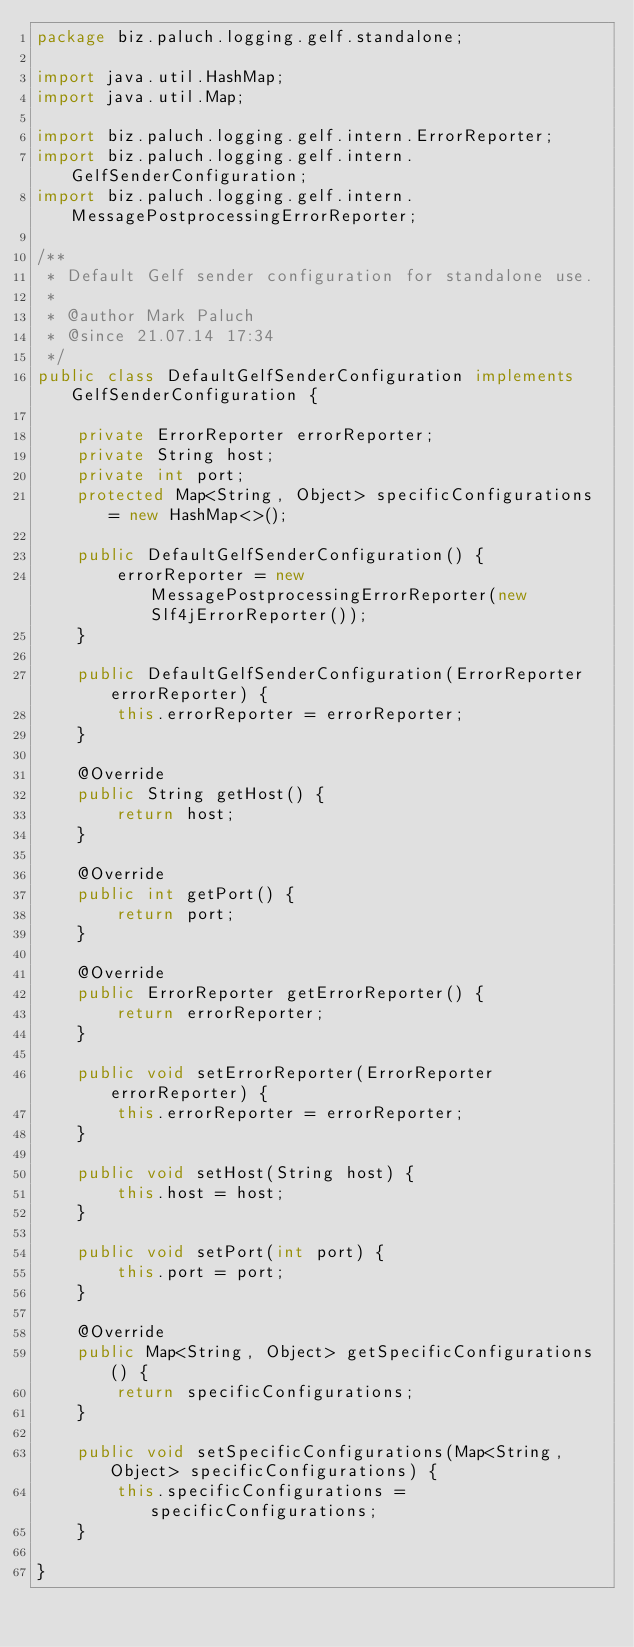<code> <loc_0><loc_0><loc_500><loc_500><_Java_>package biz.paluch.logging.gelf.standalone;

import java.util.HashMap;
import java.util.Map;

import biz.paluch.logging.gelf.intern.ErrorReporter;
import biz.paluch.logging.gelf.intern.GelfSenderConfiguration;
import biz.paluch.logging.gelf.intern.MessagePostprocessingErrorReporter;

/**
 * Default Gelf sender configuration for standalone use.
 *
 * @author Mark Paluch
 * @since 21.07.14 17:34
 */
public class DefaultGelfSenderConfiguration implements GelfSenderConfiguration {

    private ErrorReporter errorReporter;
    private String host;
    private int port;
    protected Map<String, Object> specificConfigurations = new HashMap<>();

    public DefaultGelfSenderConfiguration() {
        errorReporter = new MessagePostprocessingErrorReporter(new Slf4jErrorReporter());
    }

    public DefaultGelfSenderConfiguration(ErrorReporter errorReporter) {
        this.errorReporter = errorReporter;
    }

    @Override
    public String getHost() {
        return host;
    }

    @Override
    public int getPort() {
        return port;
    }

    @Override
    public ErrorReporter getErrorReporter() {
        return errorReporter;
    }

    public void setErrorReporter(ErrorReporter errorReporter) {
        this.errorReporter = errorReporter;
    }

    public void setHost(String host) {
        this.host = host;
    }

    public void setPort(int port) {
        this.port = port;
    }

    @Override
    public Map<String, Object> getSpecificConfigurations() {
        return specificConfigurations;
    }

    public void setSpecificConfigurations(Map<String, Object> specificConfigurations) {
        this.specificConfigurations = specificConfigurations;
    }

}
</code> 